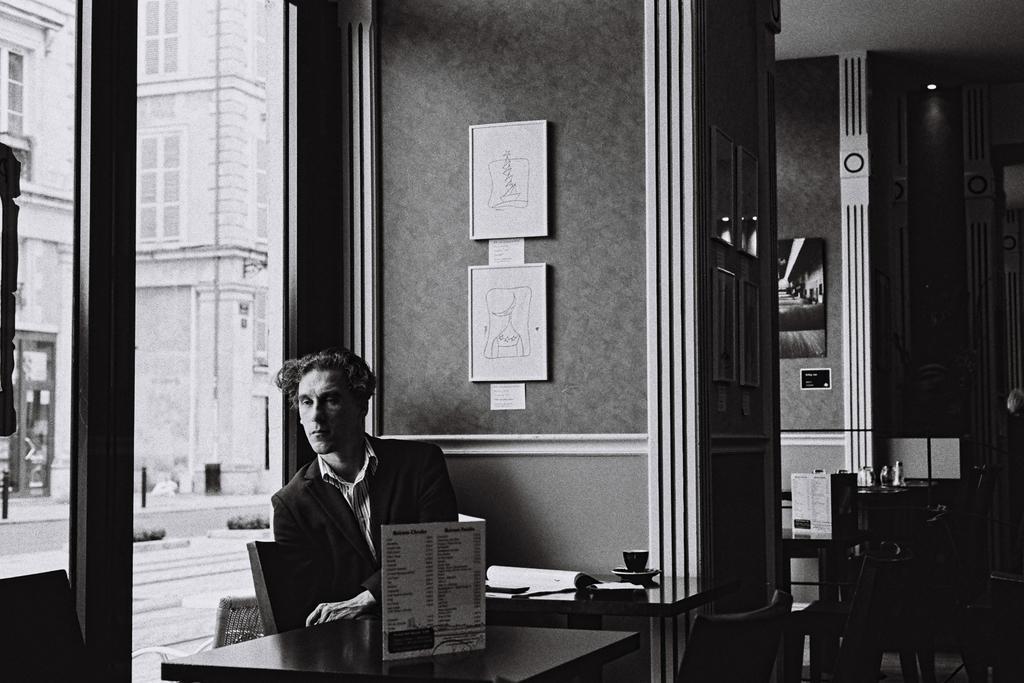Could you give a brief overview of what you see in this image? In this picture I can observe a man sitting on the chair in front of the table. I can observe photo frames on the wall in the middle of the picture. In the background I can observe building. 